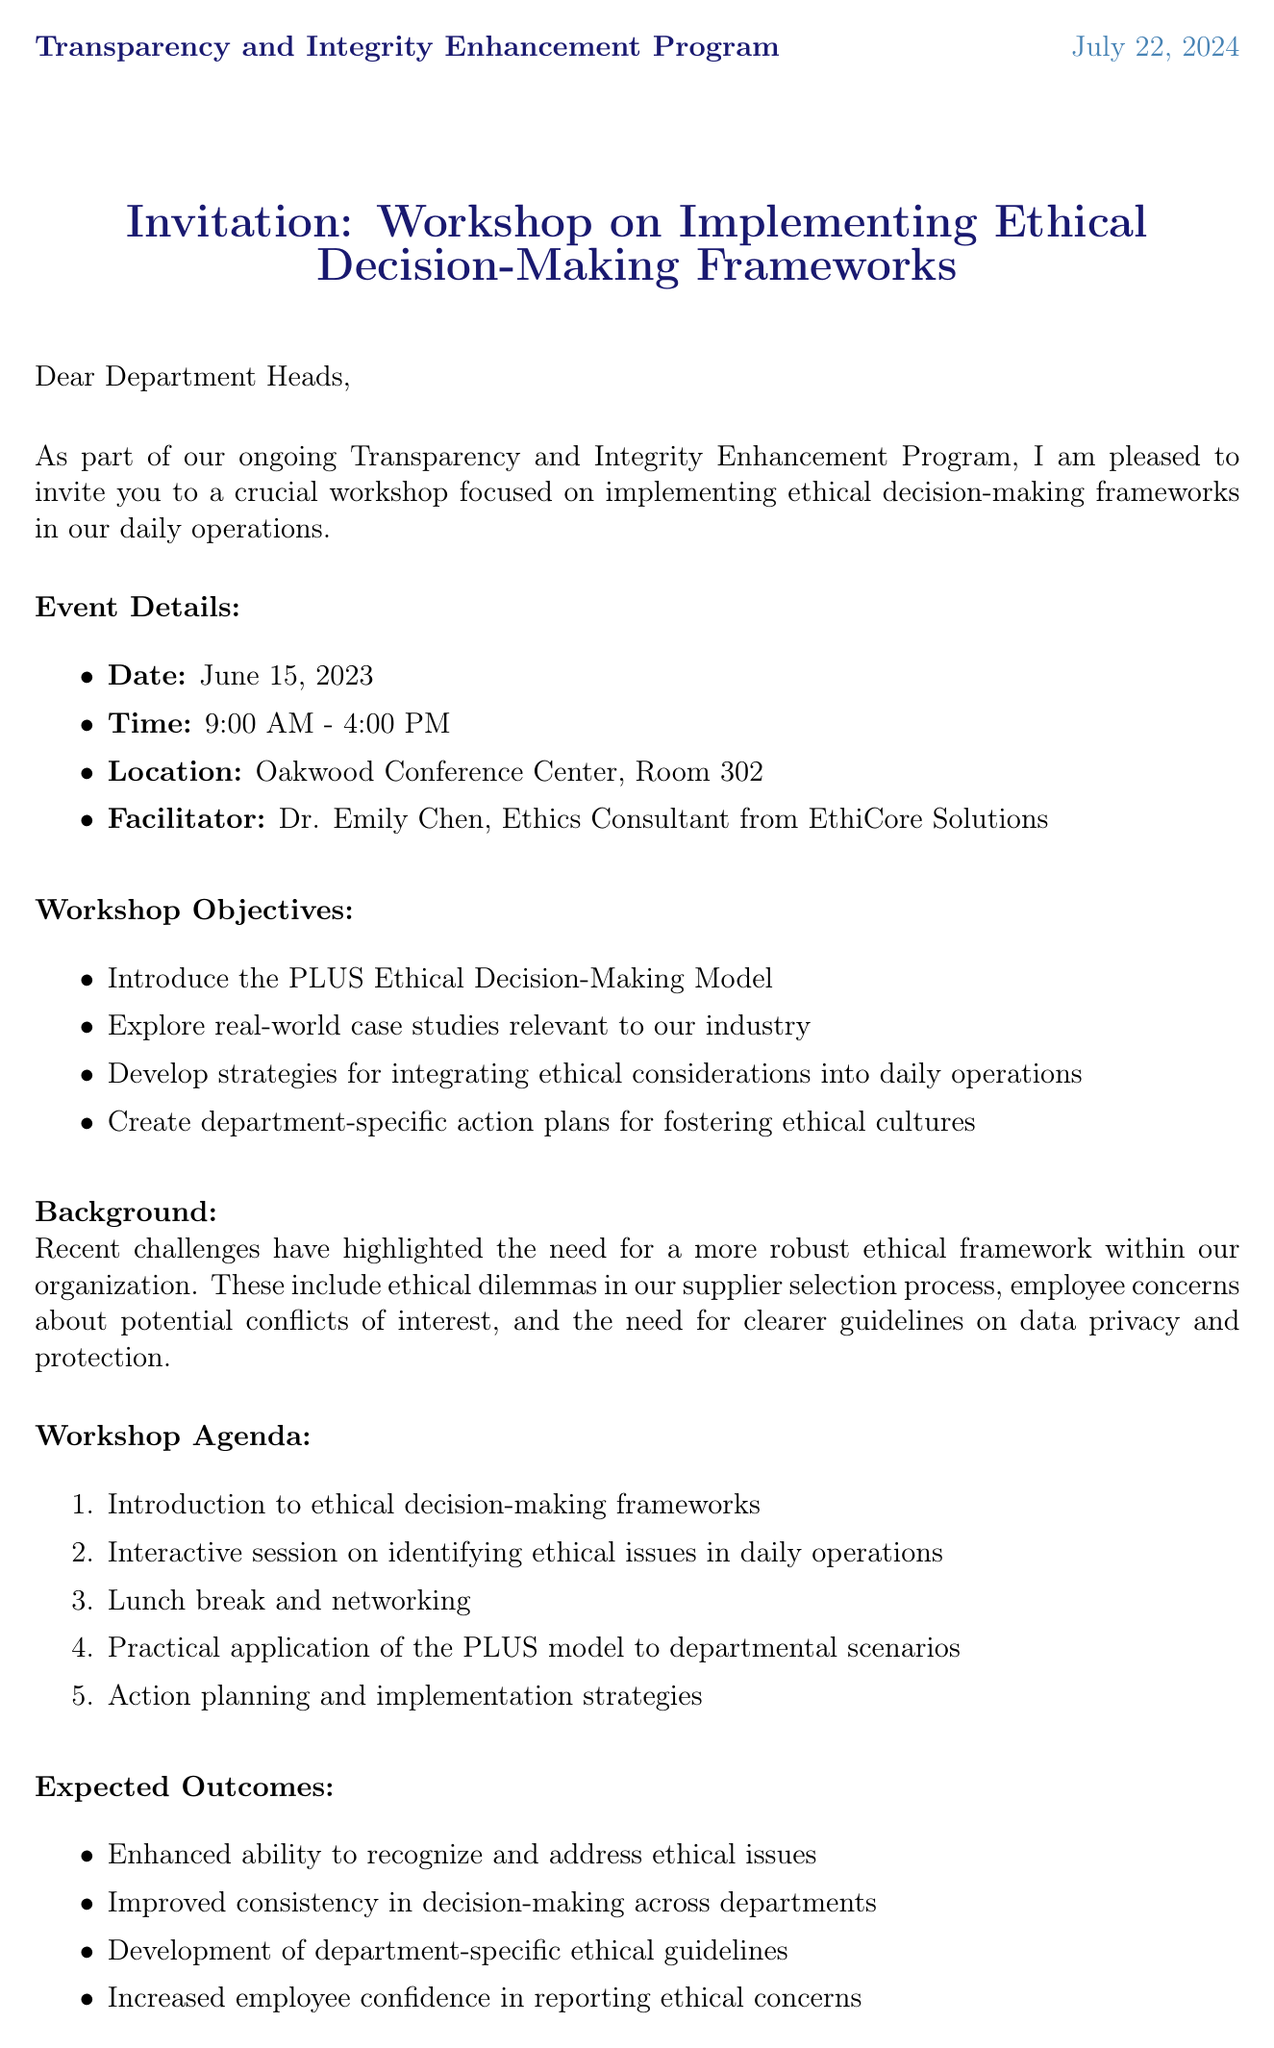what is the date of the workshop? The date of the workshop is explicitly mentioned in the document as June 15, 2023.
Answer: June 15, 2023 who is the facilitator of the workshop? The facilitator's name is provided in the event details of the document as Dr. Emily Chen.
Answer: Dr. Emily Chen what is one objective of the workshop? The document lists multiple objectives, one of which is to introduce the PLUS Ethical Decision-Making Model.
Answer: Introduce the PLUS Ethical Decision-Making Model what is the maximum duration of the workshop? The document specifies the workshop time from 9:00 AM to 4:00 PM, which covers a maximum of 7 hours.
Answer: 7 hours what materials should be reviewed before the workshop? The document lists preparatory materials including "Harvard Business Review article: 'How to Design an Ethical Organization'".
Answer: Harvard Business Review article: 'How to Design an Ethical Organization' why is this workshop being held? The workshop is part of the Transparency and Integrity Enhancement Program, aimed at addressing recent ethical challenges in the organization.
Answer: Transparency and Integrity Enhancement Program what should participants do to confirm their attendance? The RSVP instructions specify that participants should confirm their attendance by emailing Sarah Johnson.
Answer: Email Sarah Johnson when is the RSVP deadline? The document clearly states that the RSVP deadline is June 8, 2023.
Answer: June 8, 2023 